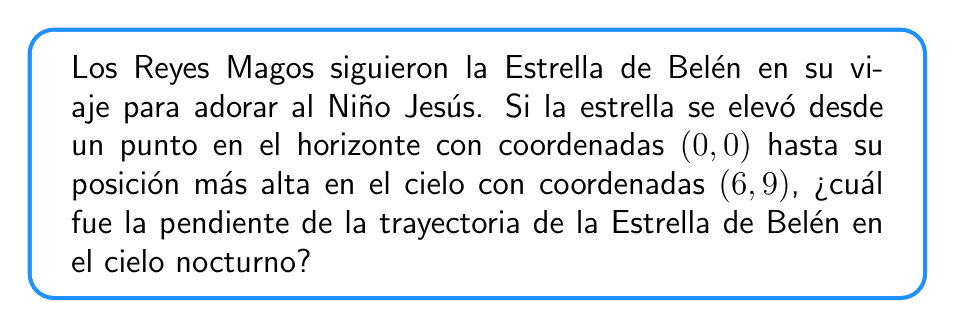Show me your answer to this math problem. Para encontrar la pendiente de la trayectoria de la Estrella de Belén, usaremos la fórmula de la pendiente:

$$ m = \frac{y_2 - y_1}{x_2 - x_1} $$

Donde:
$(x_1, y_1)$ es el punto inicial (0, 0)
$(x_2, y_2)$ es el punto final (6, 9)

Sustituyendo estos valores en la fórmula:

$$ m = \frac{9 - 0}{6 - 0} = \frac{9}{6} $$

Simplificando la fracción:

$$ m = \frac{3}{2} = 1.5 $$

Esta pendiente significa que por cada unidad horizontal que la estrella se movió, se elevó 1.5 unidades verticalmente. Esto representa el camino ascendente que la Estrella de Belén siguió en el cielo, guiando a los Reyes Magos hacia el lugar donde nació el Salvador.
Answer: La pendiente de la trayectoria de la Estrella de Belén en el cielo nocturno es $\frac{3}{2}$ o 1.5. 